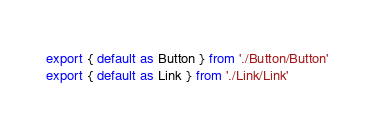<code> <loc_0><loc_0><loc_500><loc_500><_TypeScript_>export { default as Button } from './Button/Button'
export { default as Link } from './Link/Link'</code> 